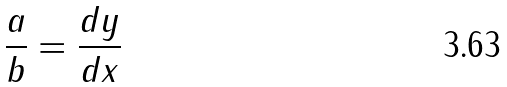Convert formula to latex. <formula><loc_0><loc_0><loc_500><loc_500>\frac { a } { b } = \frac { d y } { d x }</formula> 